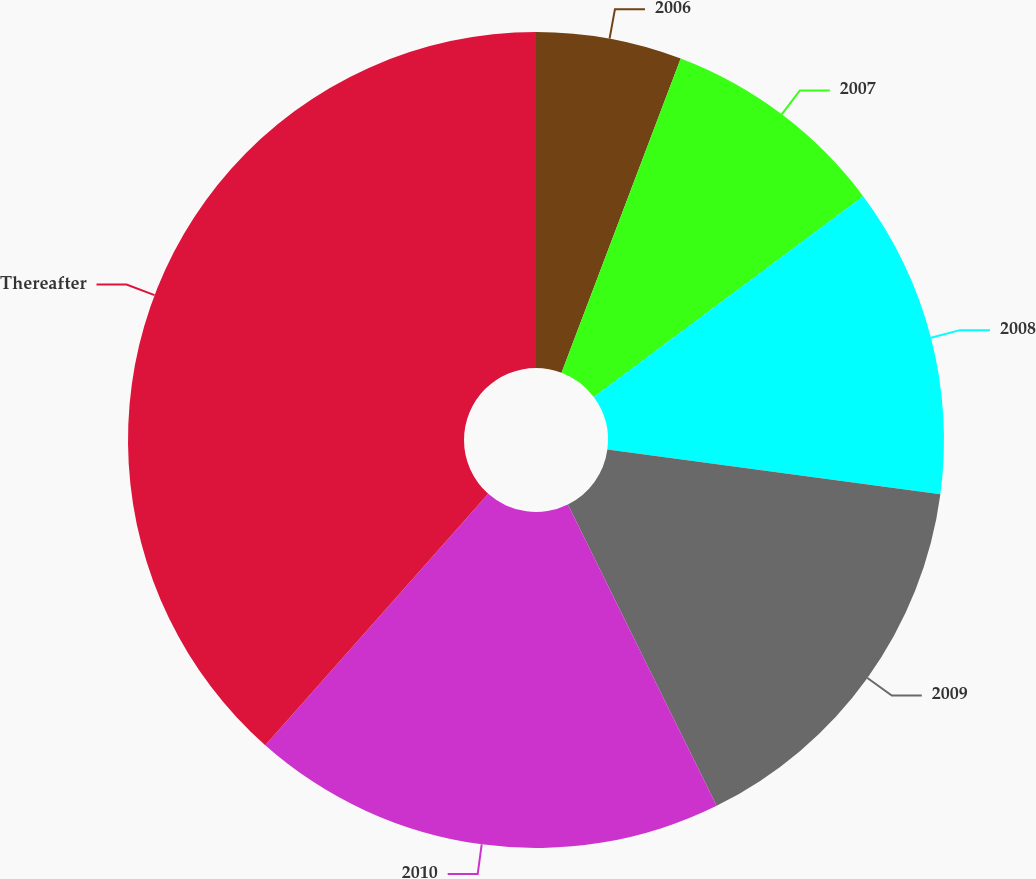<chart> <loc_0><loc_0><loc_500><loc_500><pie_chart><fcel>2006<fcel>2007<fcel>2008<fcel>2009<fcel>2010<fcel>Thereafter<nl><fcel>5.77%<fcel>9.04%<fcel>12.31%<fcel>15.58%<fcel>18.85%<fcel>38.45%<nl></chart> 